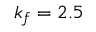Convert formula to latex. <formula><loc_0><loc_0><loc_500><loc_500>k _ { f } = 2 . 5</formula> 